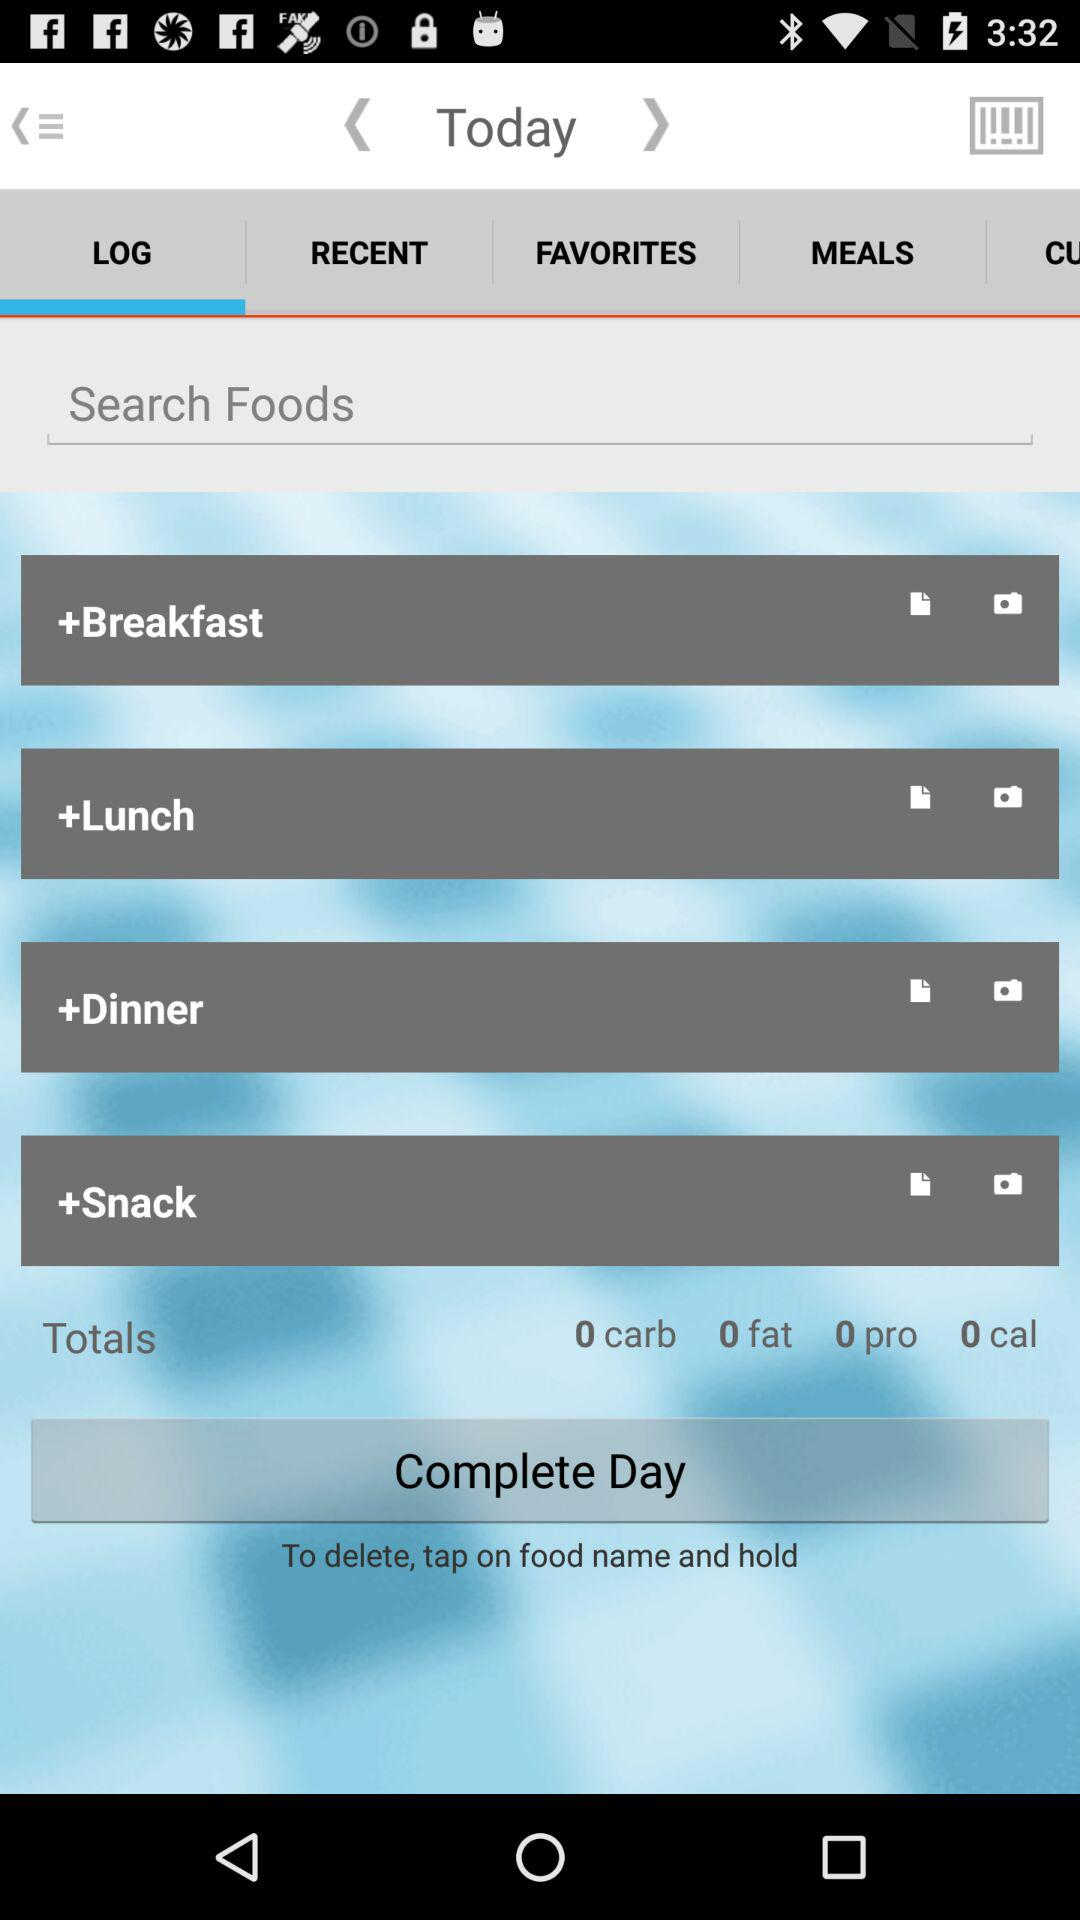How many carbs in total are there? There are 0 carbs. 